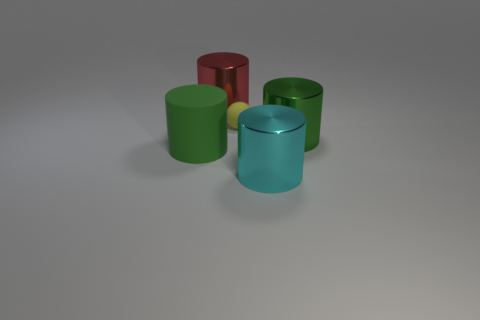Subtract 1 cylinders. How many cylinders are left? 3 Add 5 tiny objects. How many objects exist? 10 Subtract all cylinders. How many objects are left? 1 Subtract 0 red balls. How many objects are left? 5 Subtract all big gray rubber objects. Subtract all red metallic cylinders. How many objects are left? 4 Add 1 large green shiny things. How many large green shiny things are left? 2 Add 5 yellow rubber spheres. How many yellow rubber spheres exist? 6 